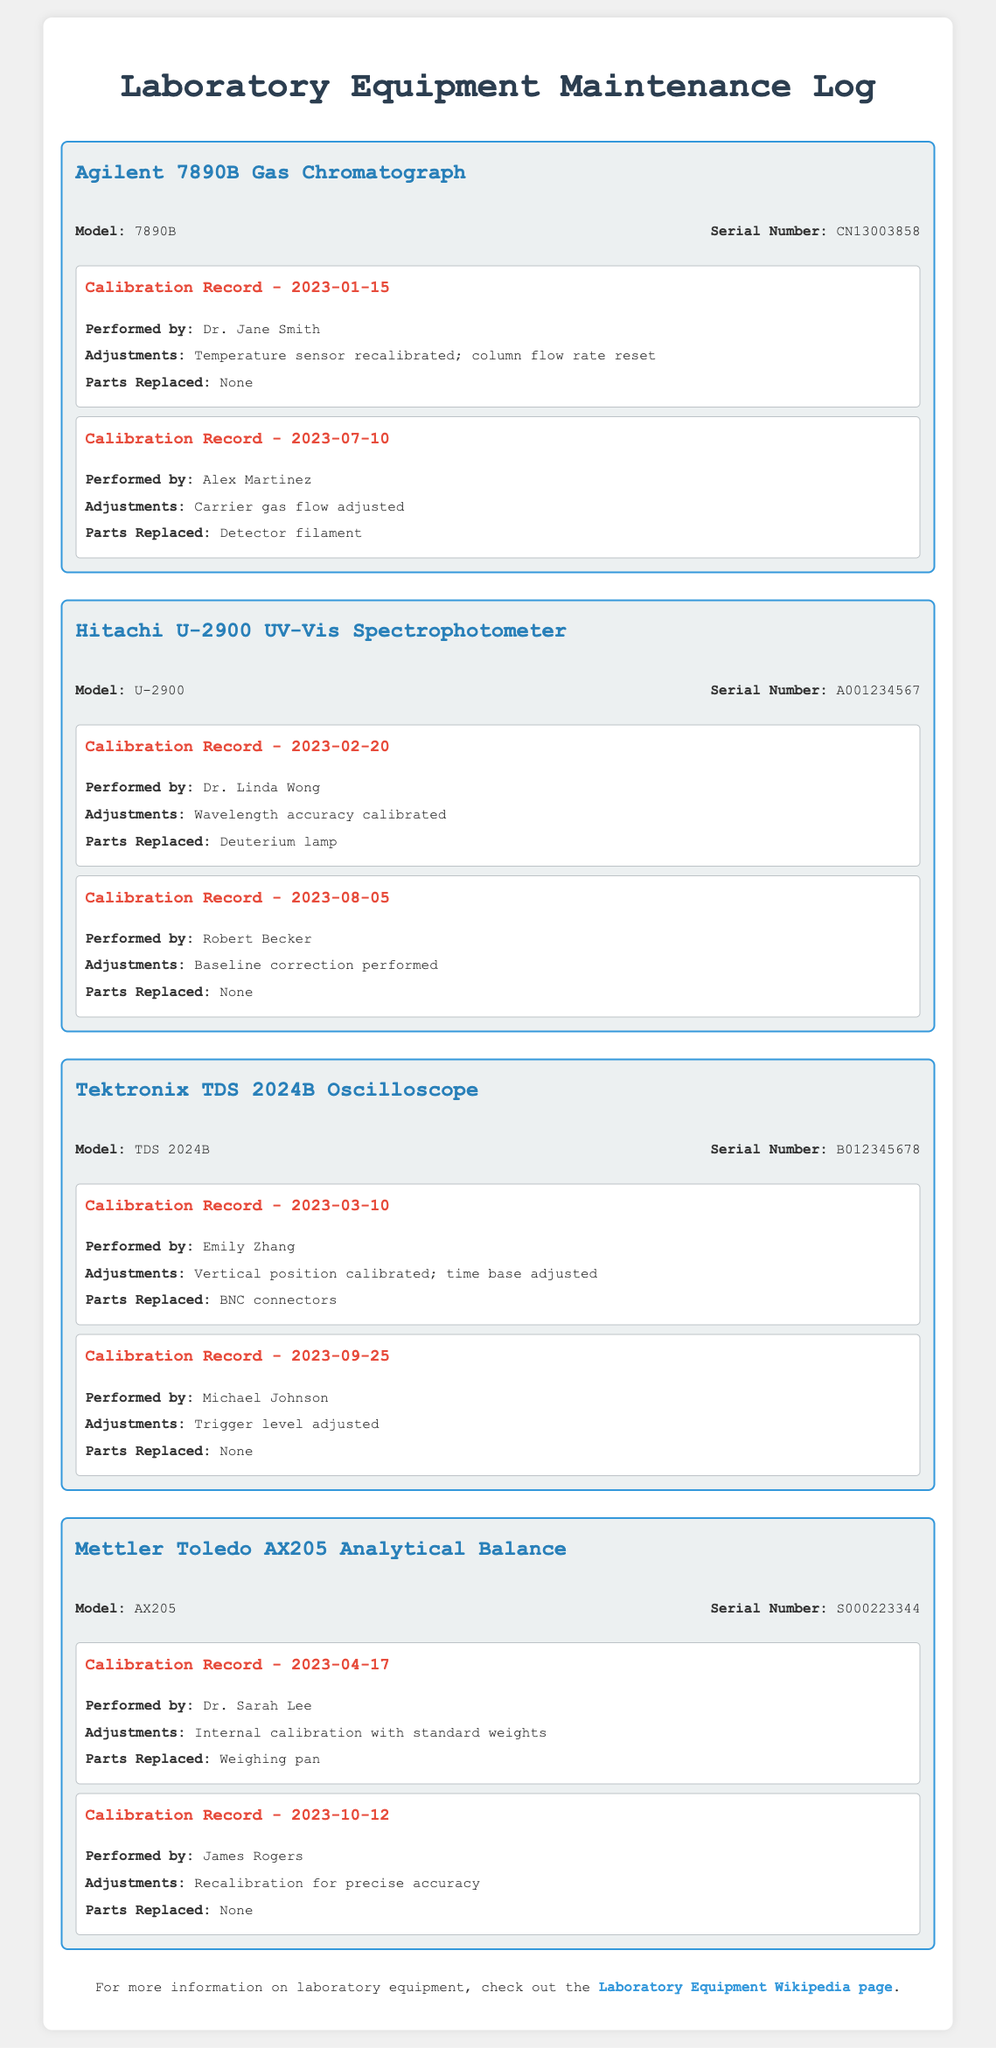what is the model of the first equipment? The first equipment listed is the Agilent 7890B Gas Chromatograph, as indicated at the top of its section.
Answer: Agilent 7890B when was the last calibration of the Hitachi U-2900 UV-Vis Spectrophotometer? The last calibration date for the Hitachi U-2900 is found in the calibration records section for this equipment.
Answer: 2023-08-05 who performed the calibration on 2023-04-17? The name of the person who performed the calibration on this date is found in the calibration record for the Mettler Toledo AX205.
Answer: Dr. Sarah Lee how many parts were replaced during the calibration of the Tektronix TDS 2024B on 2023-03-10? The number of parts replaced is listed in the corresponding calibration record for this equipment.
Answer: 1 what adjustments were made to the Agilent 7890B on 2023-01-15? The adjustments made during this calibration are specified in the log entry for that date.
Answer: Temperature sensor recalibrated; column flow rate reset which equipment had a deuterium lamp replaced? The equipment with this specific replacement noted is mentioned in the calibration details.
Answer: Hitachi U-2900 UV-Vis Spectrophotometer who was the last person to perform a calibration on the Mettler Toledo AX205? The last person to perform a calibration is provided in the final calibration record for this equipment.
Answer: James Rogers how many calibration records are listed for the Tektronix TDS 2024B? The total number of calibration records can be determined by counting the entries in the section dedicated to this equipment.
Answer: 2 